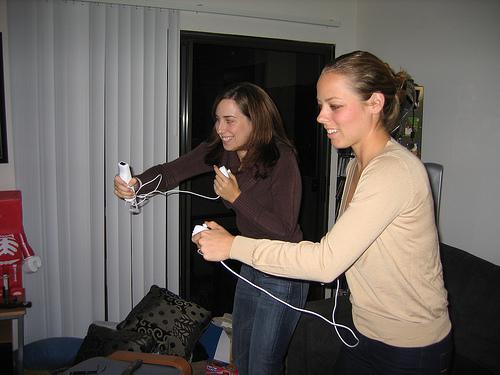How is their attire similar?
Answer briefly. Sweaters. Are the girls happy?
Answer briefly. Yes. How many ponytail holders are in the girl's hair?
Answer briefly. 1. Which player appears to be enjoying the game more?
Concise answer only. Left player. What game system are the girls playing?
Write a very short answer. Wii. 